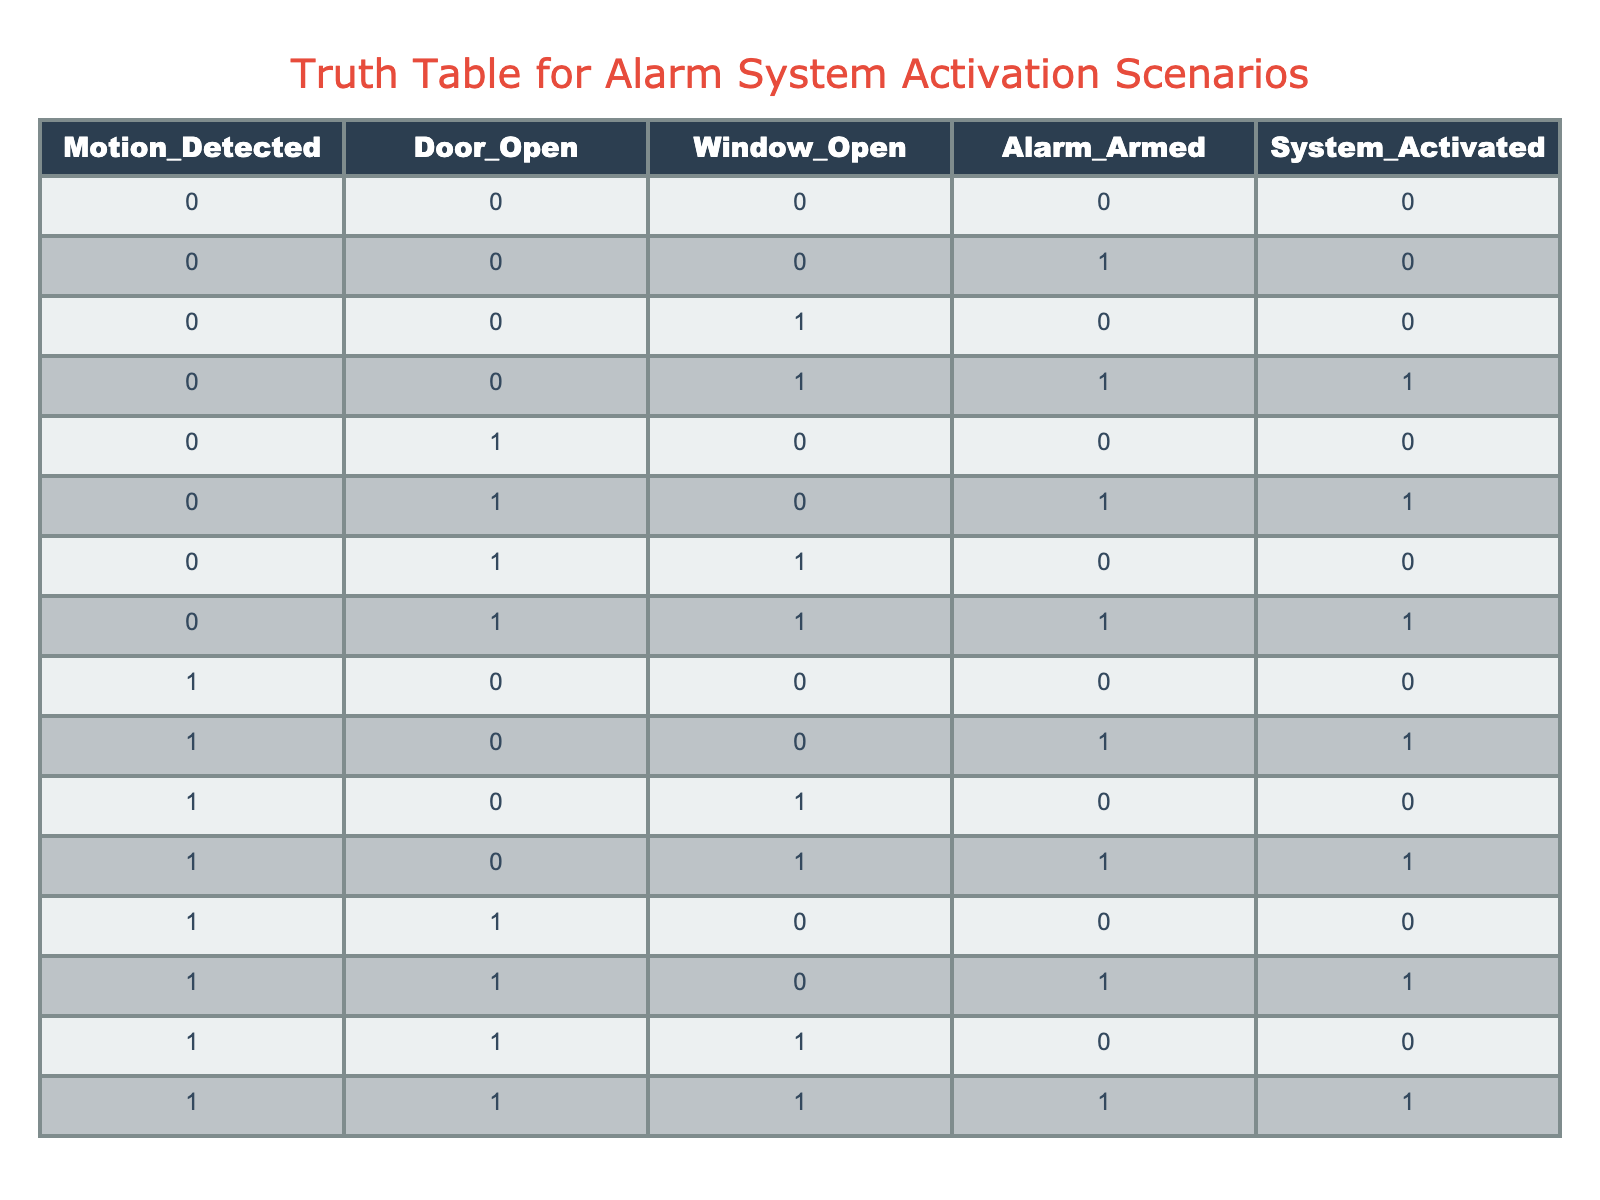What is the system status when the alarm is armed and both the door and window are closed? In the case where the alarm is armed (valued as 1), the door and window being closed (both values are 0) corresponds to the first row of the table where the system remains deactivated (0).
Answer: 0 How many scenarios lead to the activation of the alarm? The table shows 7 instances where the system is activated (1). By counting the rows with a '1' in the System_Activated column, the scenarios are at row 4, 6, 11, 14, and 16. That totals to 7 scenarios which activate the alarm.
Answer: 7 Is the alarm activated when windows are open, and the door is closed with the alarm system armed? For the scenario where the window is open (1), door closed (0), and alarm armed (1), we can refer to row 11 of the table, which indicates that the alarm is activated (1).
Answer: Yes What is the result when the door is open, windows are closed, and the alarm is unarmed? Here, the door being open (1), the windows closed (0), and the alarm unarmed (0) corresponds to row 5 of the table, which shows that the system is not activated (0).
Answer: 0 What is the proportion of scenarios where motion is detected that results in alarm activation? In the table, there are 8 scenarios with motion detected (1) in rows 9, 11, 13, 15, and all but rows 1, 2, 3, 4 are accounted. Out of these, 4 instances activate the alarm, making the proportion 4 out of 8 or 50%.
Answer: 50% When the alarm is armed, how many unique scenarios of activation can be identified based solely on door states? Analyzing the activation based solely on door states while the alarm is armed, rows 6, 11, 14, and 16 represent unique combinations; that's a total of 4 unique scenarios where activation occurs while the door is either open or closed with the alarm on.
Answer: 4 Are there any scenarios where the alarm is not activated even when motion is detected? Reviewing the rows, we need to check for instances with motion detected (value 1) where the system remains inactive. In row 9, with motion detected and all else unarmed, the system does not activate, confirming at least one situation exists.
Answer: Yes What is the condition where the system activates with both doors and windows open? Looking specifically at the rows involving both door (1) and window (1) opened alongside the alarm being armed, only row 16 fulfills this whereby both opening conditions lead to activation (1).
Answer: Activated 